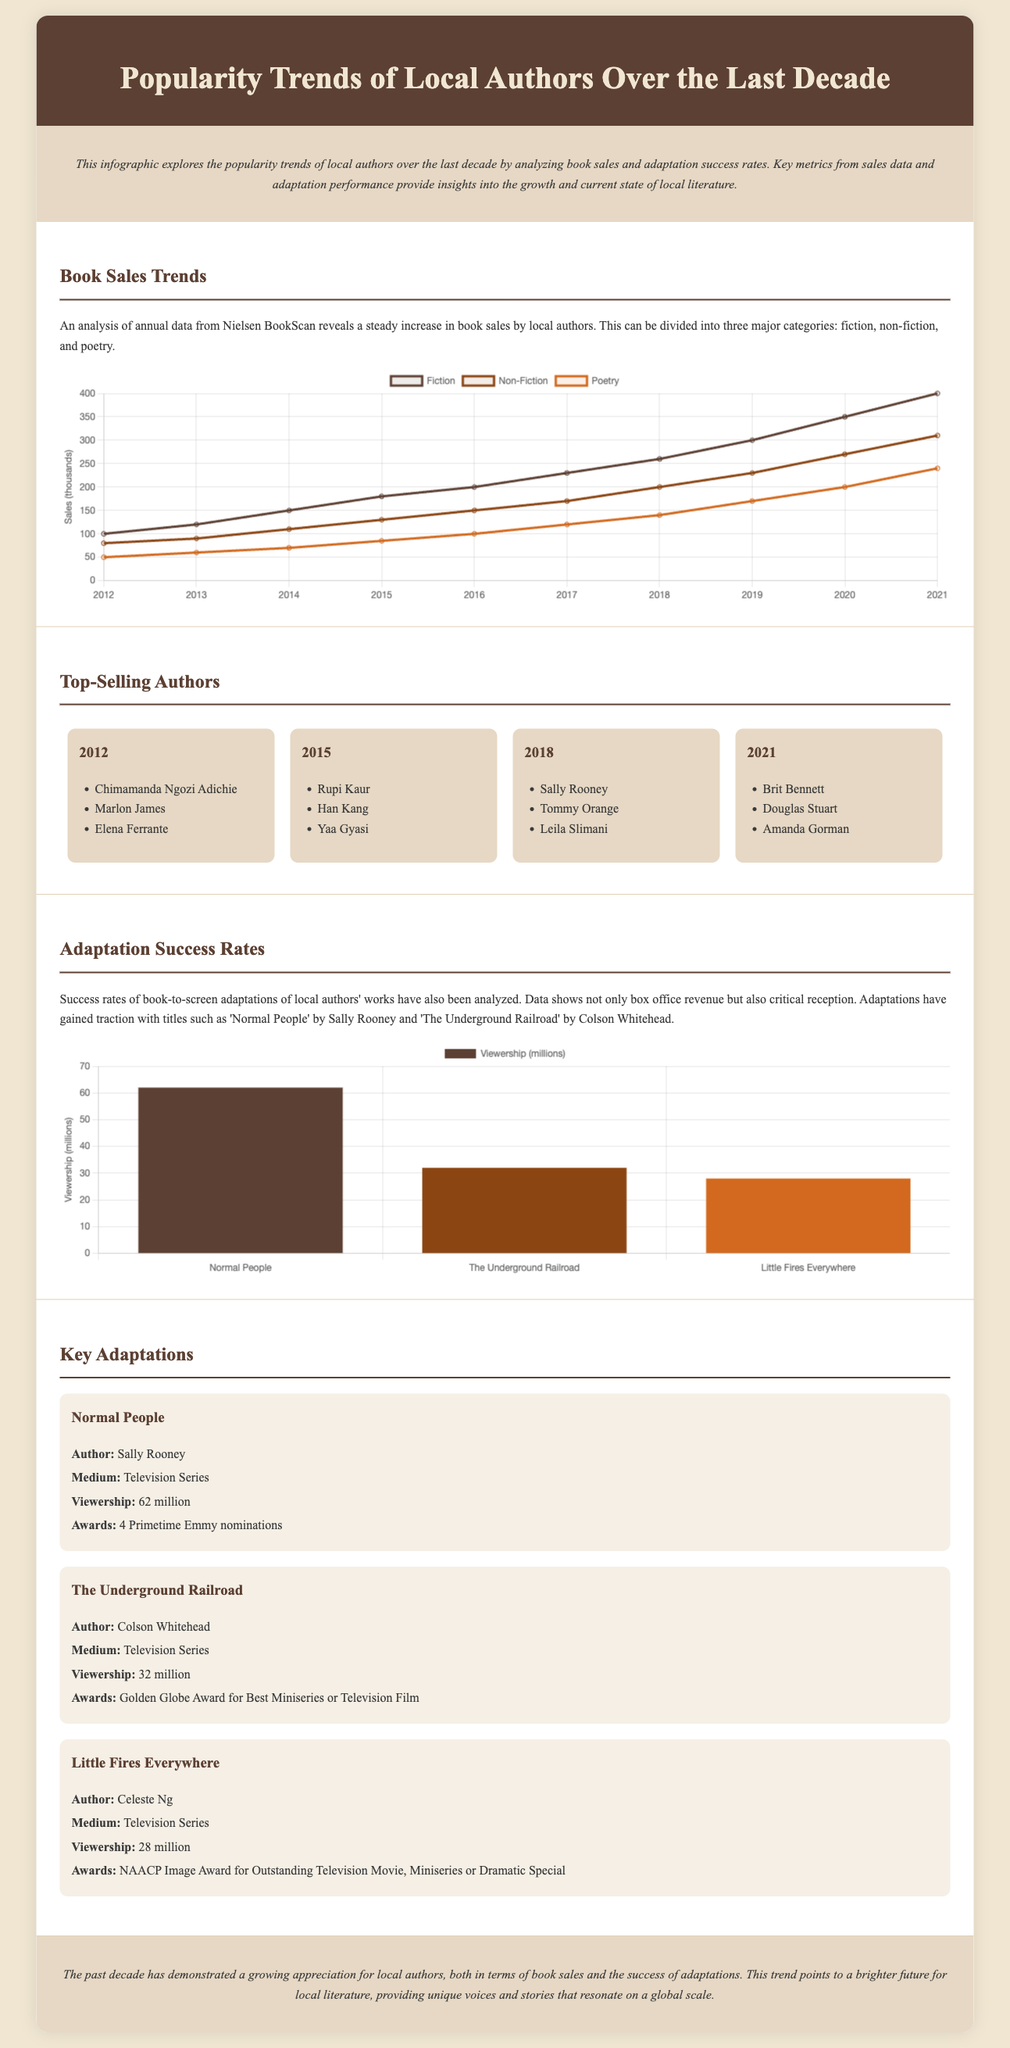What is the title of the infographic? The title is prominently displayed at the top of the document, stating the main focus of the content.
Answer: Popularity Trends of Local Authors Over the Last Decade Which author had the highest viewership for their adaptation? The viewership metrics in the adaptation section highlight the most successful adaptation based on the number of viewers.
Answer: Sally Rooney What year saw the highest book sales in fiction? The chart showing book sales trends indicates that the peak sales for fiction occurred in a specific year.
Answer: 2021 How many authors are listed as top-selling in 2015? The section on top-selling authors in individual years provides a list of authors for a given year, counting the total number for that year.
Answer: 3 What is the total viewership for 'The Underground Railroad'? The data presented shows the specific viewership figure associated with this adaptation, providing a clear number.
Answer: 32 million Which category of books showed steady growth in sales over the decade? The document describes trends in book sales and identifies the categories that have increased consistently over the years.
Answer: All categories What award was won by 'The Underground Railroad'? The adaptation section lists the recognition received for specific adaptations, highlighting key awards for one title.
Answer: Golden Globe Award for Best Miniseries or Television Film How many Primetime Emmy nominations did 'Normal People' receive? The information provided in the adaptation details section specifies the total number of nominations for this adaptation.
Answer: 4 